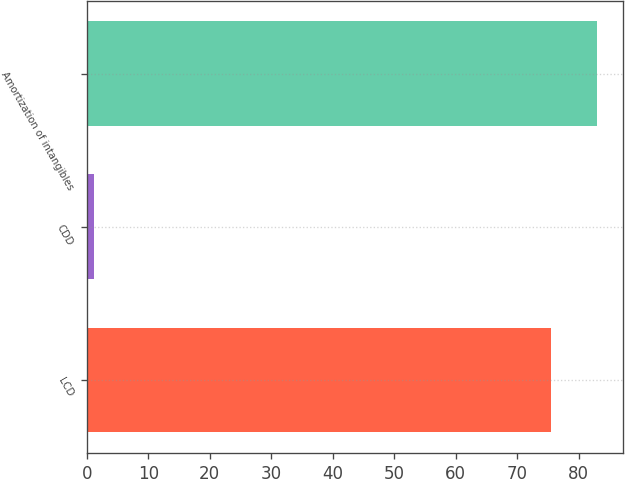<chart> <loc_0><loc_0><loc_500><loc_500><bar_chart><fcel>LCD<fcel>CDD<fcel>Amortization of intangibles<nl><fcel>75.5<fcel>1.2<fcel>83.05<nl></chart> 